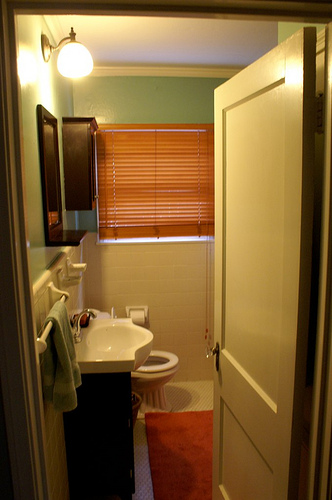What color is the wall in the background? The wall in the background is painted a light teal or aqua color, which adds a fresh and calming vibe to the space. 